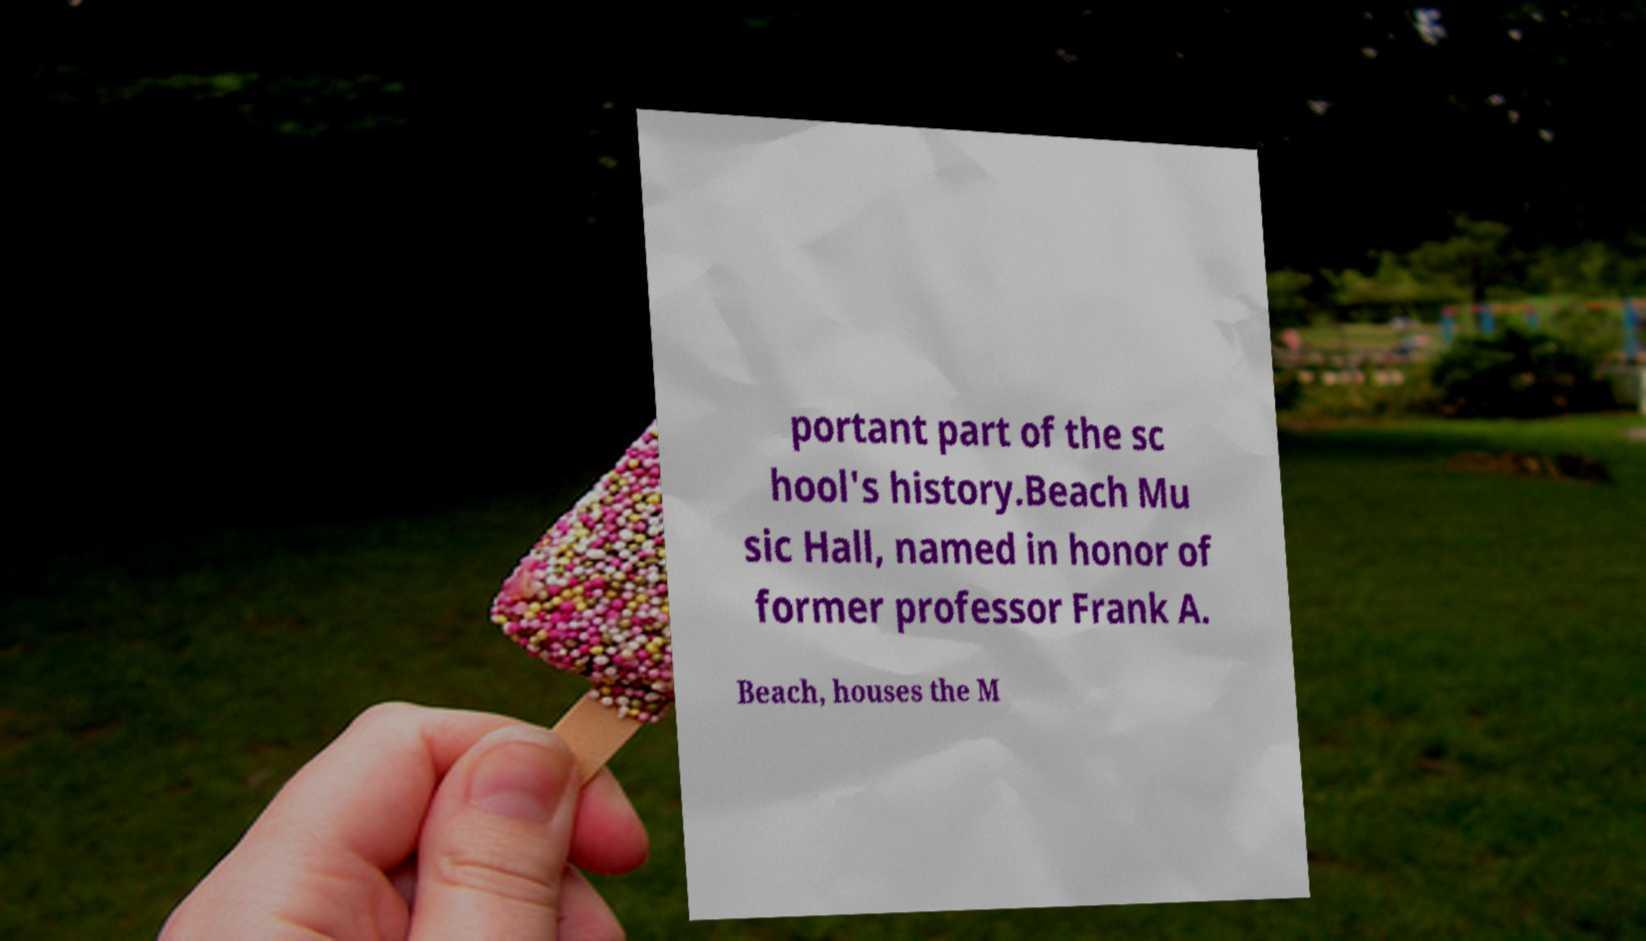Please read and relay the text visible in this image. What does it say? portant part of the sc hool's history.Beach Mu sic Hall, named in honor of former professor Frank A. Beach, houses the M 